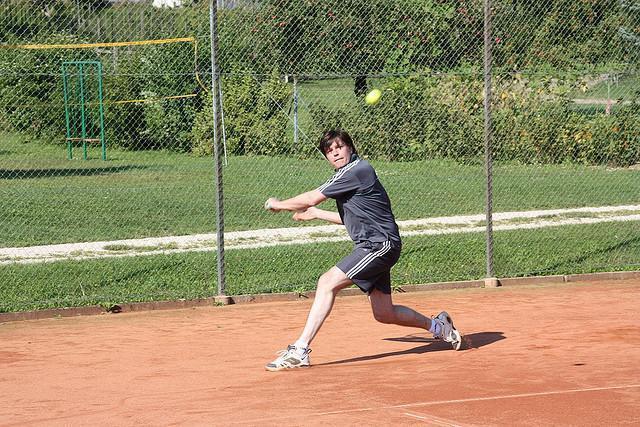Where is the boy playing?
Indicate the correct response by choosing from the four available options to answer the question.
Options: Arena, park, gym, stadium. Park. 